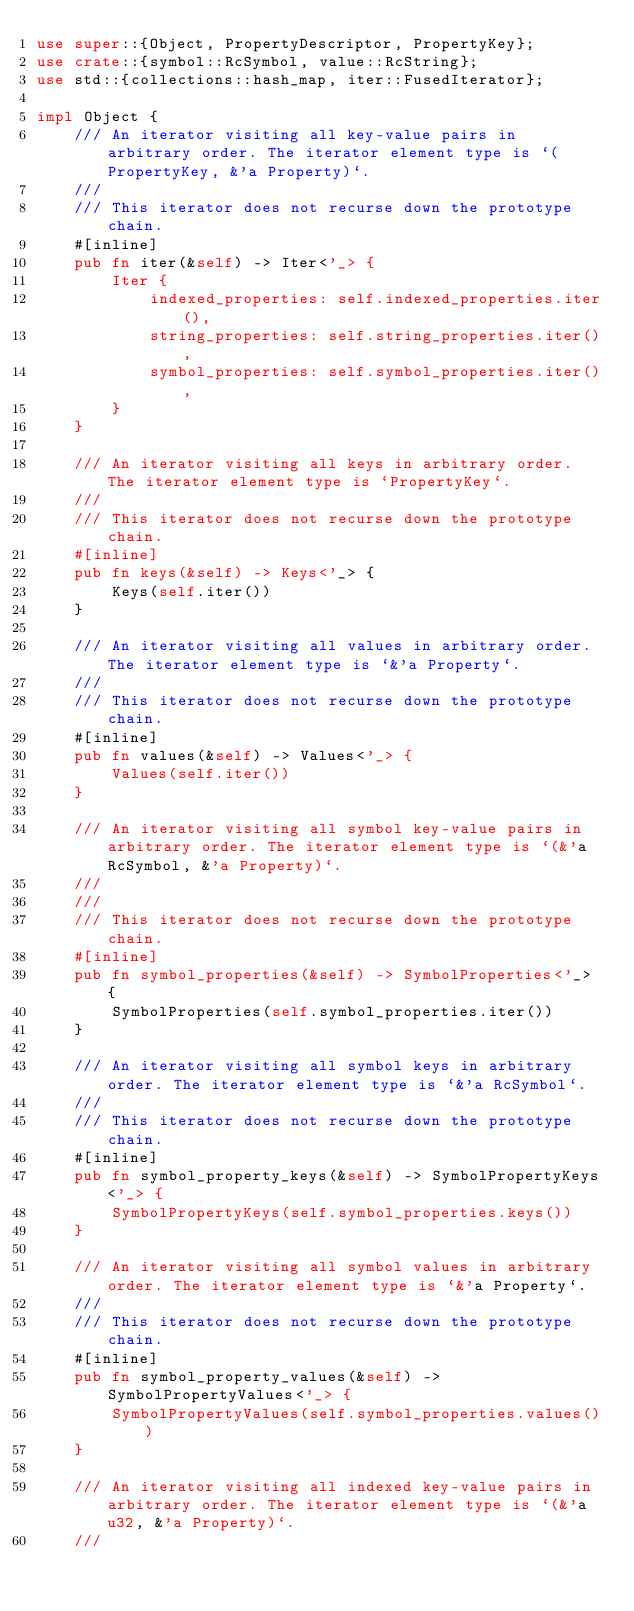<code> <loc_0><loc_0><loc_500><loc_500><_Rust_>use super::{Object, PropertyDescriptor, PropertyKey};
use crate::{symbol::RcSymbol, value::RcString};
use std::{collections::hash_map, iter::FusedIterator};

impl Object {
    /// An iterator visiting all key-value pairs in arbitrary order. The iterator element type is `(PropertyKey, &'a Property)`.
    ///
    /// This iterator does not recurse down the prototype chain.
    #[inline]
    pub fn iter(&self) -> Iter<'_> {
        Iter {
            indexed_properties: self.indexed_properties.iter(),
            string_properties: self.string_properties.iter(),
            symbol_properties: self.symbol_properties.iter(),
        }
    }

    /// An iterator visiting all keys in arbitrary order. The iterator element type is `PropertyKey`.
    ///
    /// This iterator does not recurse down the prototype chain.
    #[inline]
    pub fn keys(&self) -> Keys<'_> {
        Keys(self.iter())
    }

    /// An iterator visiting all values in arbitrary order. The iterator element type is `&'a Property`.
    ///
    /// This iterator does not recurse down the prototype chain.
    #[inline]
    pub fn values(&self) -> Values<'_> {
        Values(self.iter())
    }

    /// An iterator visiting all symbol key-value pairs in arbitrary order. The iterator element type is `(&'a RcSymbol, &'a Property)`.
    ///
    ///
    /// This iterator does not recurse down the prototype chain.
    #[inline]
    pub fn symbol_properties(&self) -> SymbolProperties<'_> {
        SymbolProperties(self.symbol_properties.iter())
    }

    /// An iterator visiting all symbol keys in arbitrary order. The iterator element type is `&'a RcSymbol`.
    ///
    /// This iterator does not recurse down the prototype chain.
    #[inline]
    pub fn symbol_property_keys(&self) -> SymbolPropertyKeys<'_> {
        SymbolPropertyKeys(self.symbol_properties.keys())
    }

    /// An iterator visiting all symbol values in arbitrary order. The iterator element type is `&'a Property`.
    ///
    /// This iterator does not recurse down the prototype chain.
    #[inline]
    pub fn symbol_property_values(&self) -> SymbolPropertyValues<'_> {
        SymbolPropertyValues(self.symbol_properties.values())
    }

    /// An iterator visiting all indexed key-value pairs in arbitrary order. The iterator element type is `(&'a u32, &'a Property)`.
    ///</code> 